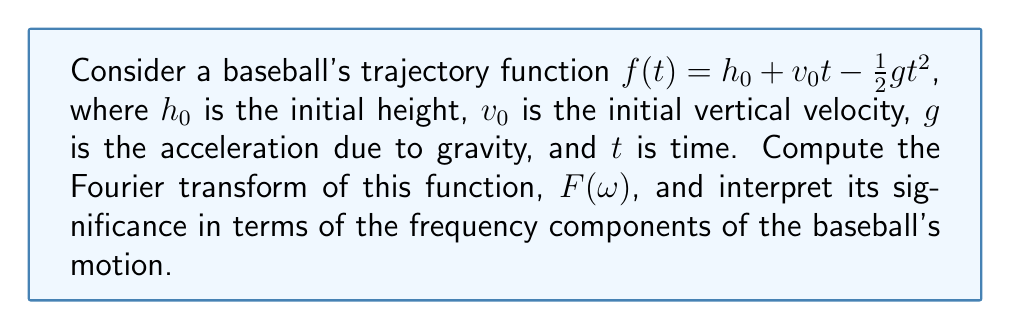Could you help me with this problem? Let's approach this step-by-step:

1) The Fourier transform of a function $f(t)$ is given by:

   $$F(\omega) = \int_{-\infty}^{\infty} f(t) e^{-i\omega t} dt$$

2) Substituting our trajectory function:

   $$F(\omega) = \int_{-\infty}^{\infty} (h_0 + v_0t - \frac{1}{2}gt^2) e^{-i\omega t} dt$$

3) We can split this into three integrals:

   $$F(\omega) = h_0 \int_{-\infty}^{\infty} e^{-i\omega t} dt + v_0 \int_{-\infty}^{\infty} t e^{-i\omega t} dt - \frac{1}{2}g \int_{-\infty}^{\infty} t^2 e^{-i\omega t} dt$$

4) These integrals are well-known:

   - $\int_{-\infty}^{\infty} e^{-i\omega t} dt = 2\pi \delta(\omega)$
   - $\int_{-\infty}^{\infty} t e^{-i\omega t} dt = -2\pi i \delta'(\omega)$
   - $\int_{-\infty}^{\infty} t^2 e^{-i\omega t} dt = -2\pi \delta''(\omega)$

   Where $\delta(\omega)$ is the Dirac delta function and $\delta'(\omega)$, $\delta''(\omega)$ are its derivatives.

5) Substituting these results:

   $$F(\omega) = 2\pi h_0 \delta(\omega) + 2\pi i v_0 \delta'(\omega) + \pi g \delta''(\omega)$$

6) Interpretation: The Fourier transform shows that the baseball's trajectory is composed of:
   - A constant component (represented by $\delta(\omega)$)
   - A linear component (represented by $\delta'(\omega)$)
   - A quadratic component (represented by $\delta''(\omega)$)

   This aligns with our original function having constant, linear, and quadratic terms.
Answer: $F(\omega) = 2\pi h_0 \delta(\omega) + 2\pi i v_0 \delta'(\omega) + \pi g \delta''(\omega)$ 